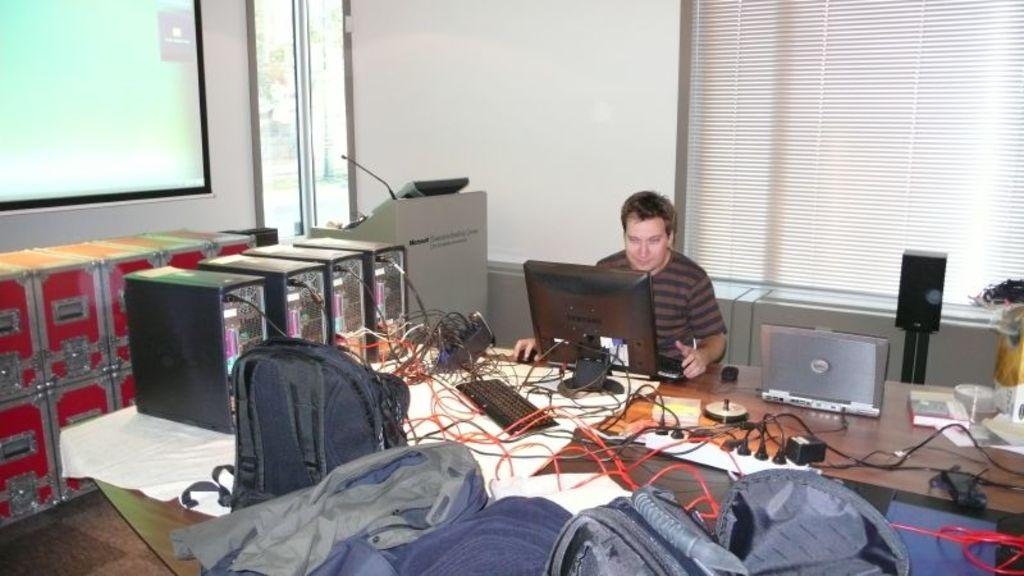What is the person in the image doing? The person is sitting and working on a laptop in the image. What can be seen on the table in front of the person? There are C.P.U. units visible on the table in the image. What type of bags are present in the image? There are bags in the image, but their contents or type are not specified. What is visible in the background of the image? There is a window and a wall in the background of the image. What type of bone can be seen in the image? There is no bone present in the image; it features a person working on a laptop with C.P.U. units and bags on the table. 